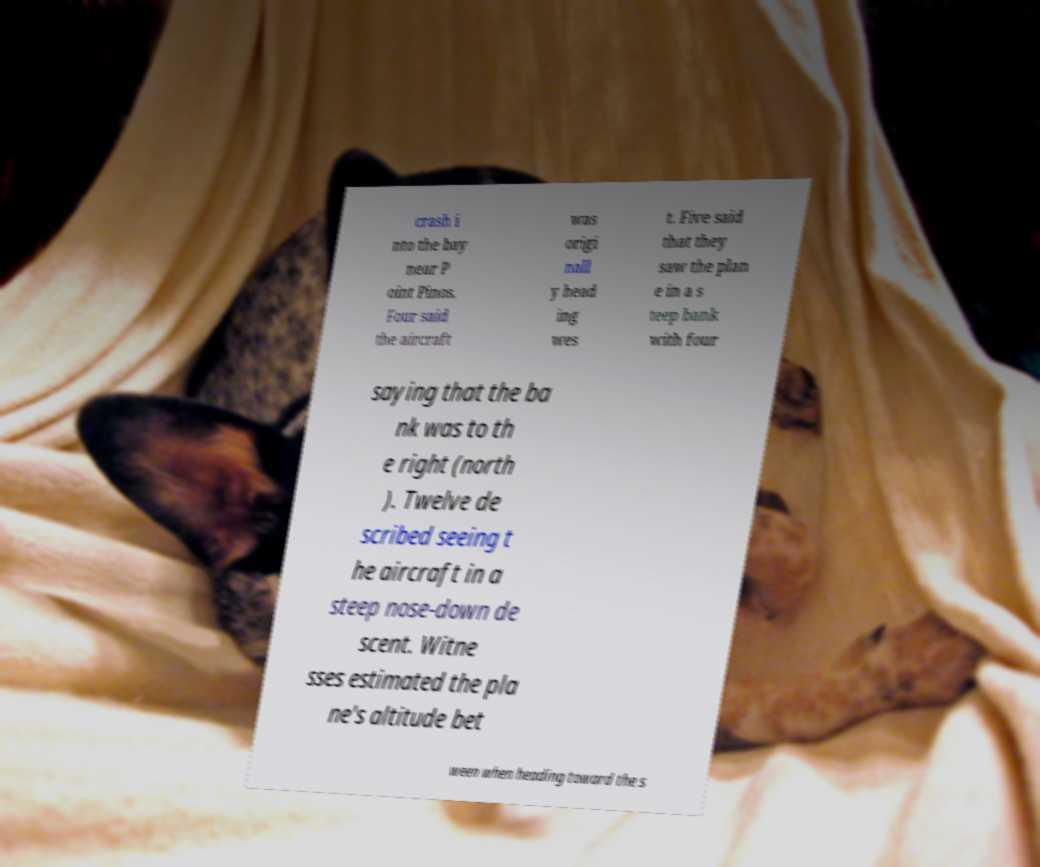Could you extract and type out the text from this image? crash i nto the bay near P oint Pinos. Four said the aircraft was origi nall y head ing wes t. Five said that they saw the plan e in a s teep bank with four saying that the ba nk was to th e right (north ). Twelve de scribed seeing t he aircraft in a steep nose-down de scent. Witne sses estimated the pla ne's altitude bet ween when heading toward the s 